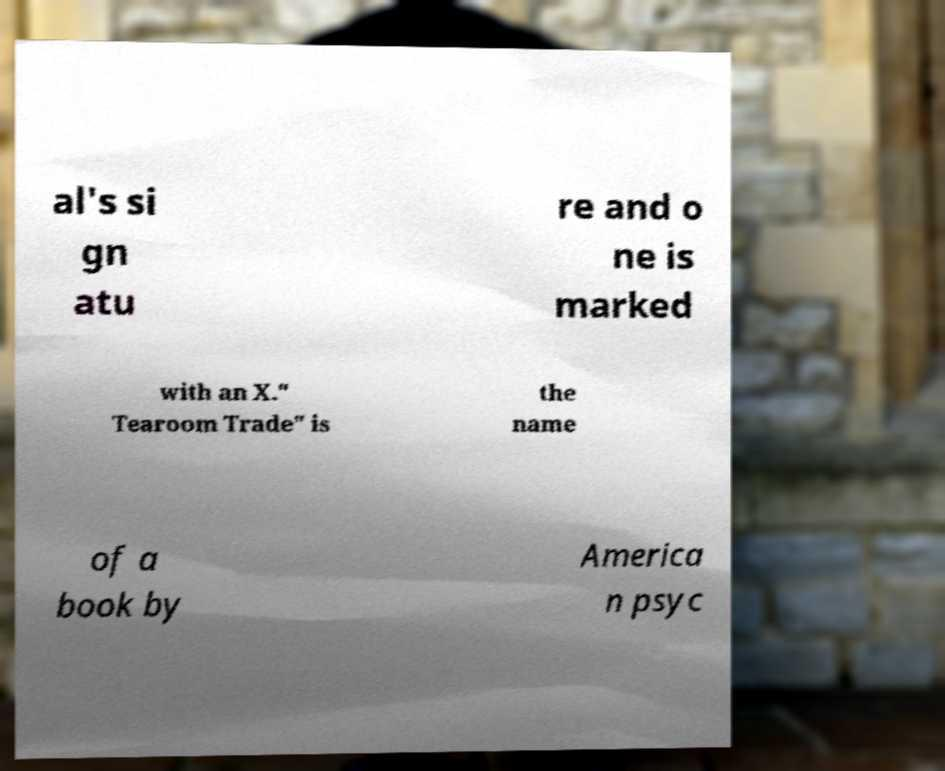I need the written content from this picture converted into text. Can you do that? al's si gn atu re and o ne is marked with an X." Tearoom Trade" is the name of a book by America n psyc 